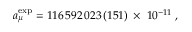Convert formula to latex. <formula><loc_0><loc_0><loc_500><loc_500>a _ { \mu } ^ { e x p } = 1 1 6 \, 5 9 2 \, 0 2 3 \, ( 1 5 1 ) \, \times \, 1 0 ^ { - 1 1 } \, ,</formula> 